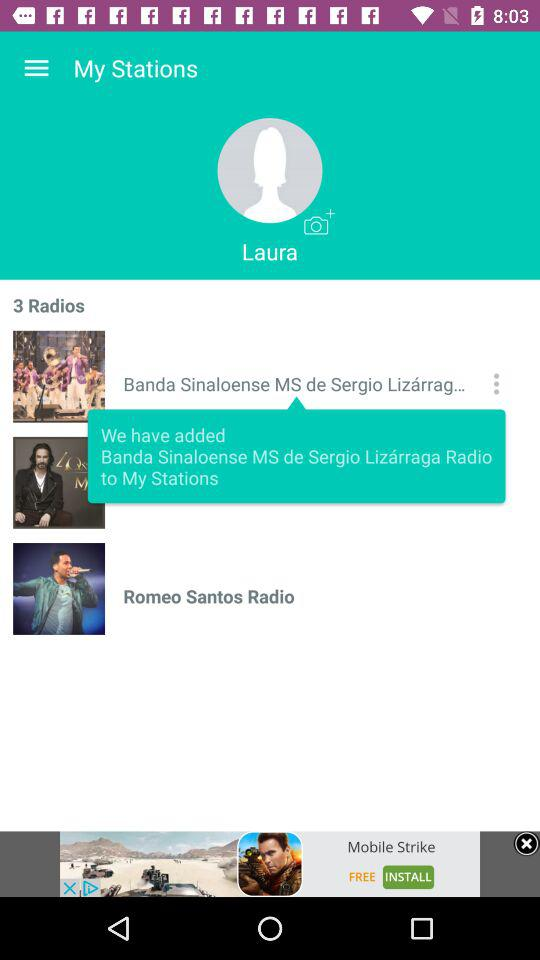What's the user profile name? The user profile name is Laura. 